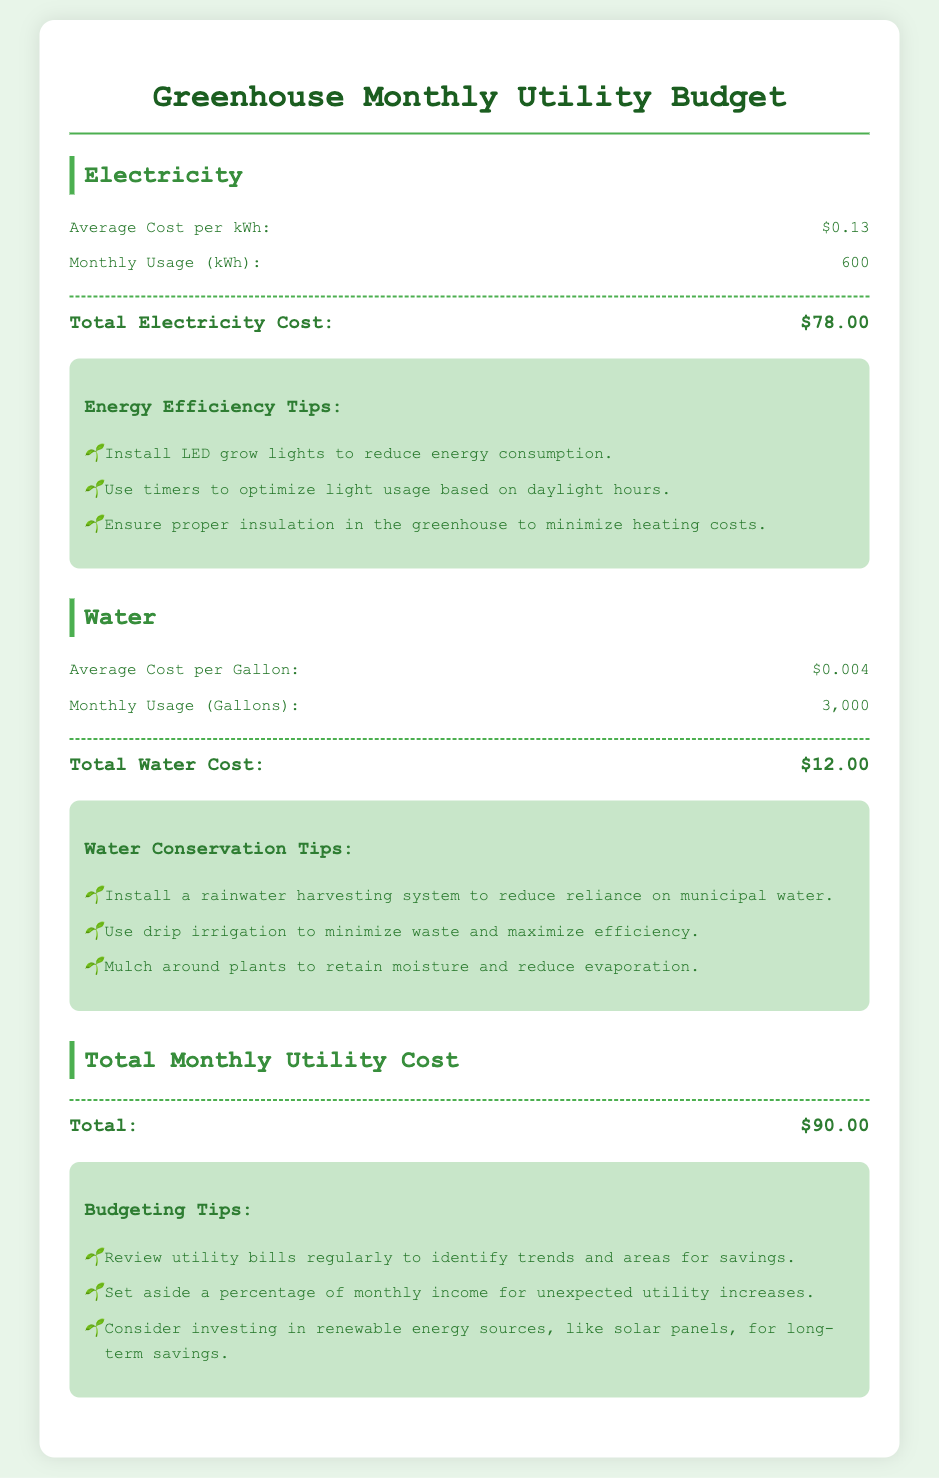what is the average cost per kWh? The average cost per kWh for electricity is listed in the document as $0.13.
Answer: $0.13 how much water is used monthly in gallons? The document states that the monthly water usage is 3,000 gallons.
Answer: 3,000 what is the total electricity cost? The total electricity cost is calculated to be $78.00 based on the provided usage and cost per kWh.
Answer: $78.00 what is the total monthly utility cost? The document summarizes the total monthly utility cost, which includes both electricity and water costs, as $90.00.
Answer: $90.00 how much is the average cost per gallon of water? The average cost per gallon of water noted in the document is $0.004.
Answer: $0.004 what type of irrigation method does the document recommend? The document recommends using drip irrigation to minimize waste and maximize efficiency.
Answer: drip irrigation what is one suggestion for energy efficiency? The document includes suggestions such as installing LED grow lights to reduce energy consumption.
Answer: install LED grow lights which utility cost is higher, electricity or water? By comparing the total costs, the document indicates that the electricity cost is higher than the water cost.
Answer: electricity what is one way to conserve water according to the document? The document suggests installing a rainwater harvesting system as a method to conserve water.
Answer: install a rainwater harvesting system 